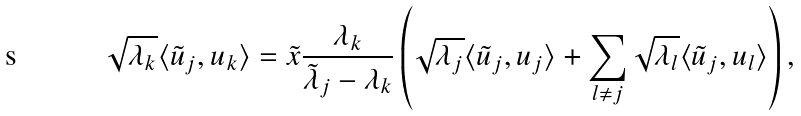<formula> <loc_0><loc_0><loc_500><loc_500>\sqrt { \lambda _ { k } } \langle \tilde { u } _ { j } , u _ { k } \rangle = \tilde { x } \frac { \lambda _ { k } } { \tilde { \lambda } _ { j } - \lambda _ { k } } \left ( \sqrt { \lambda _ { j } } \langle \tilde { u } _ { j } , u _ { j } \rangle + \sum _ { l \neq j } \sqrt { \lambda _ { l } } \langle \tilde { u } _ { j } , u _ { l } \rangle \right ) ,</formula> 